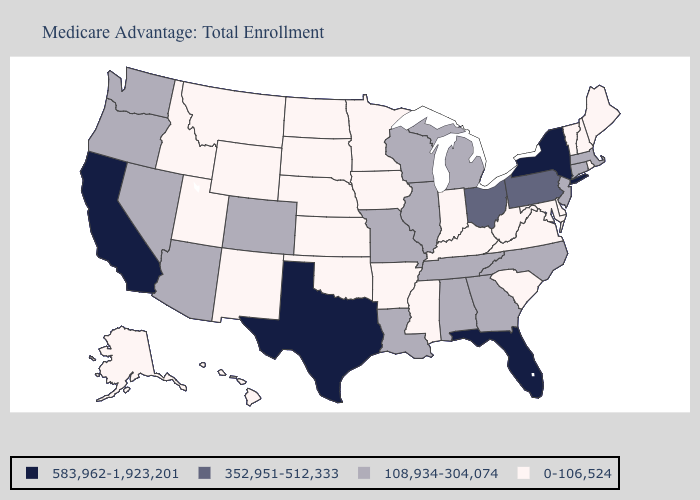Does Michigan have a lower value than New York?
Keep it brief. Yes. What is the lowest value in the USA?
Answer briefly. 0-106,524. Among the states that border Utah , does Wyoming have the highest value?
Be succinct. No. Name the states that have a value in the range 583,962-1,923,201?
Concise answer only. California, Florida, New York, Texas. Is the legend a continuous bar?
Concise answer only. No. What is the highest value in the MidWest ?
Concise answer only. 352,951-512,333. What is the value of Kansas?
Keep it brief. 0-106,524. Which states have the lowest value in the South?
Short answer required. Arkansas, Delaware, Kentucky, Maryland, Mississippi, Oklahoma, South Carolina, Virginia, West Virginia. What is the value of Wyoming?
Short answer required. 0-106,524. Does West Virginia have a lower value than Ohio?
Answer briefly. Yes. What is the lowest value in the West?
Answer briefly. 0-106,524. Among the states that border Nevada , which have the highest value?
Answer briefly. California. Which states have the lowest value in the MidWest?
Answer briefly. Iowa, Indiana, Kansas, Minnesota, North Dakota, Nebraska, South Dakota. What is the highest value in states that border Connecticut?
Give a very brief answer. 583,962-1,923,201. 